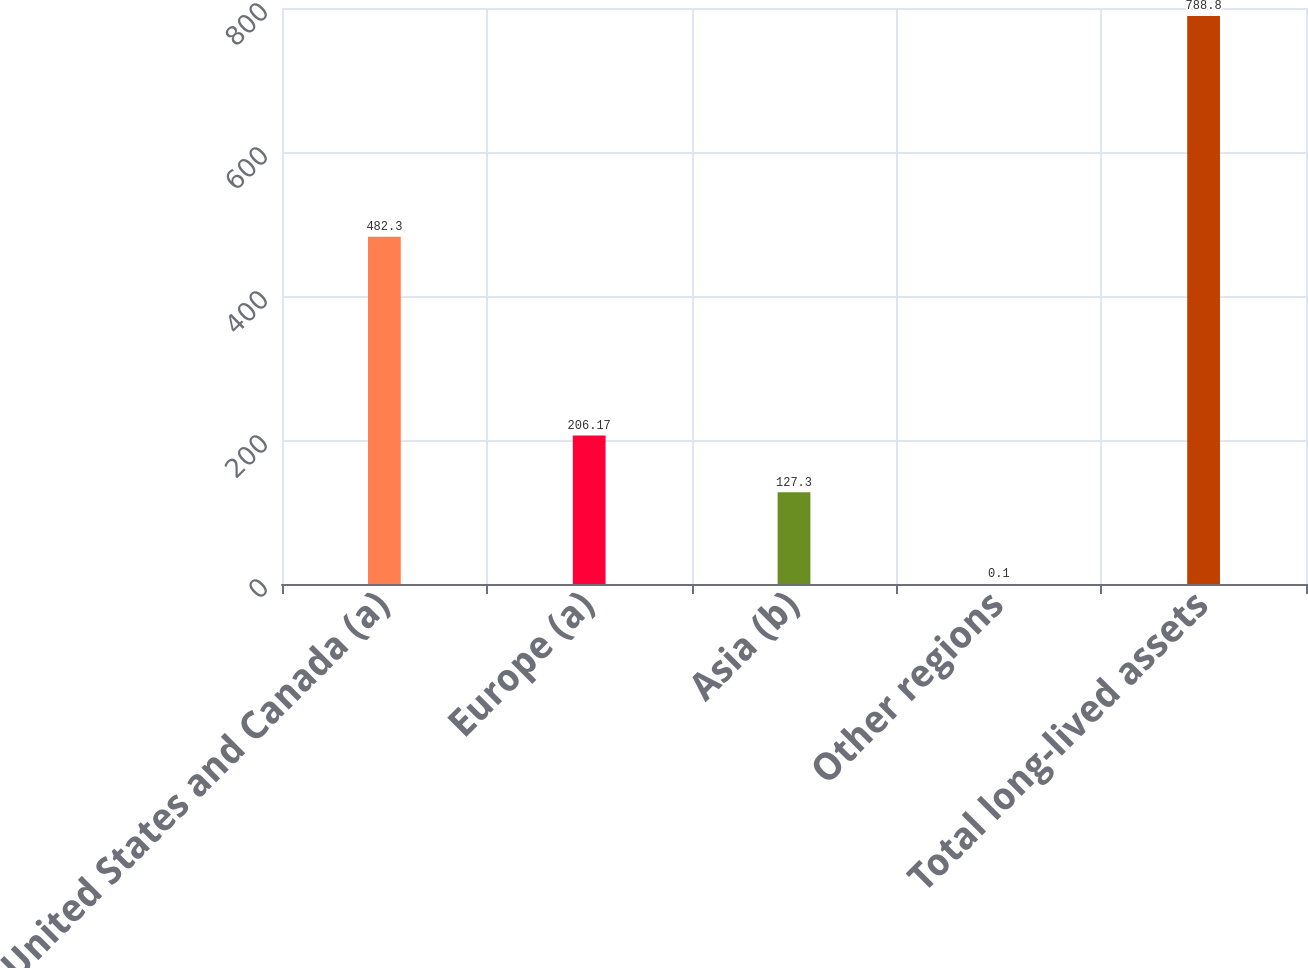<chart> <loc_0><loc_0><loc_500><loc_500><bar_chart><fcel>United States and Canada (a)<fcel>Europe (a)<fcel>Asia (b)<fcel>Other regions<fcel>Total long-lived assets<nl><fcel>482.3<fcel>206.17<fcel>127.3<fcel>0.1<fcel>788.8<nl></chart> 